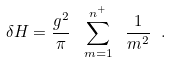<formula> <loc_0><loc_0><loc_500><loc_500>\delta H = \frac { g ^ { 2 } } { \pi } \ \sum ^ { n ^ { + } } _ { m = 1 } \ \frac { 1 } { m ^ { 2 } } \ .</formula> 